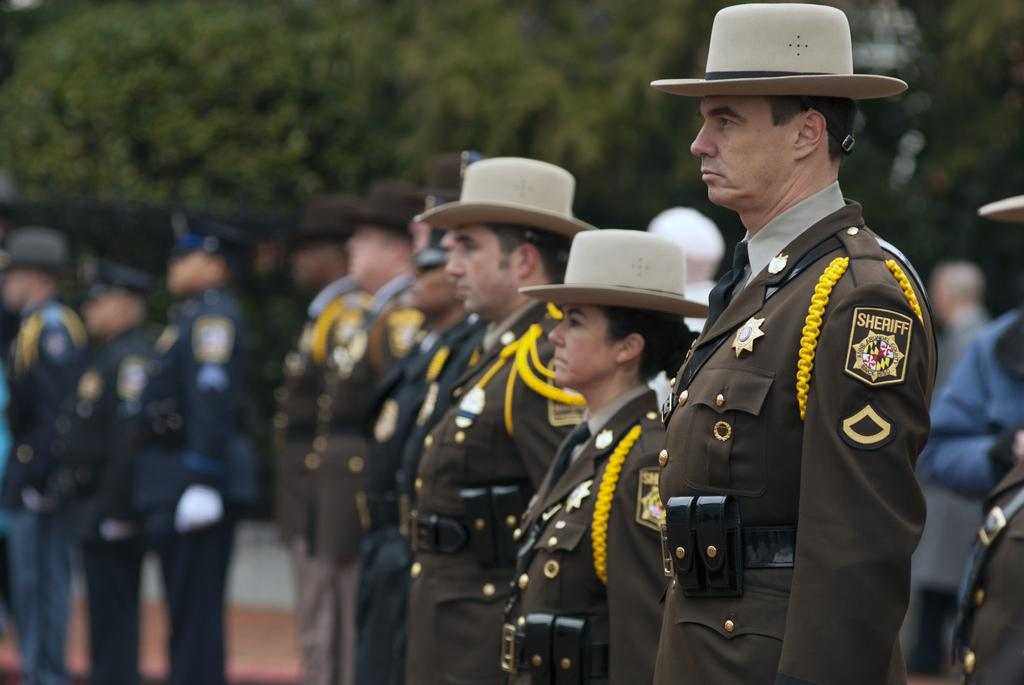What is the main subject of the image? The main subject of the image is a group of people. What are the people wearing in the image? The people are wearing caps in the image. What are the people doing in the image? The people are standing in the image. What can be seen in the background of the image? There are trees in the background of the image. What type of pleasure can be seen being enjoyed by the people in the image? There is no indication of pleasure being enjoyed by the people in the image; they are simply standing and wearing caps. 